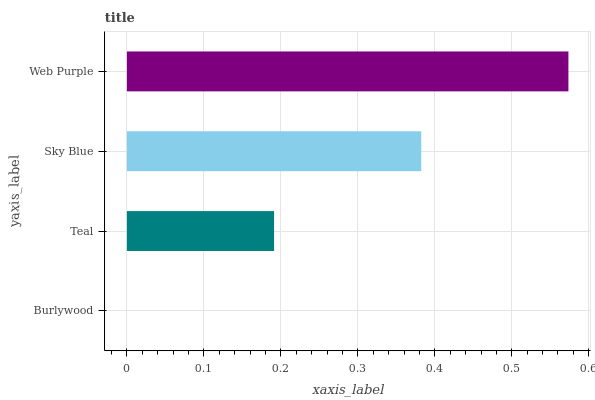Is Burlywood the minimum?
Answer yes or no. Yes. Is Web Purple the maximum?
Answer yes or no. Yes. Is Teal the minimum?
Answer yes or no. No. Is Teal the maximum?
Answer yes or no. No. Is Teal greater than Burlywood?
Answer yes or no. Yes. Is Burlywood less than Teal?
Answer yes or no. Yes. Is Burlywood greater than Teal?
Answer yes or no. No. Is Teal less than Burlywood?
Answer yes or no. No. Is Sky Blue the high median?
Answer yes or no. Yes. Is Teal the low median?
Answer yes or no. Yes. Is Teal the high median?
Answer yes or no. No. Is Web Purple the low median?
Answer yes or no. No. 